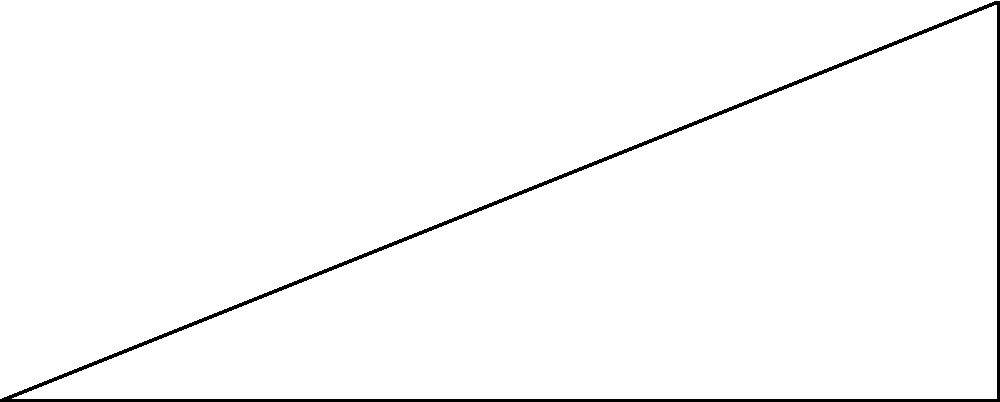While visiting a famous religious monument in a culturally rich city, you decide to calculate its height using trigonometry. Standing 50 meters away from the base of the monument, you measure the angle of elevation to the top as 30°. What is the height of the monument to the nearest meter? Let's approach this step-by-step:

1) We can model this situation as a right-angled triangle, where:
   - The base of the triangle is the distance from you to the monument (50 m)
   - The height of the triangle is the height of the monument (what we're solving for)
   - The angle between the base and the hypotenuse is 30°

2) In this right-angled triangle, we know:
   - The adjacent side (base) = 50 m
   - The angle = 30°
   - We need to find the opposite side (height)

3) This scenario calls for the use of the tangent function:

   $\tan \theta = \frac{\text{opposite}}{\text{adjacent}}$

4) Plugging in our known values:

   $\tan 30° = \frac{\text{height}}{50}$

5) Rearranging to solve for height:

   $\text{height} = 50 \times \tan 30°$

6) Calculate:
   $\text{height} = 50 \times 0.5773...$ (as $\tan 30° \approx 0.5773$)
   $\text{height} = 28.8675...$

7) Rounding to the nearest meter:
   $\text{height} \approx 29$ meters

Thus, the height of the monument is approximately 29 meters.
Answer: 29 meters 